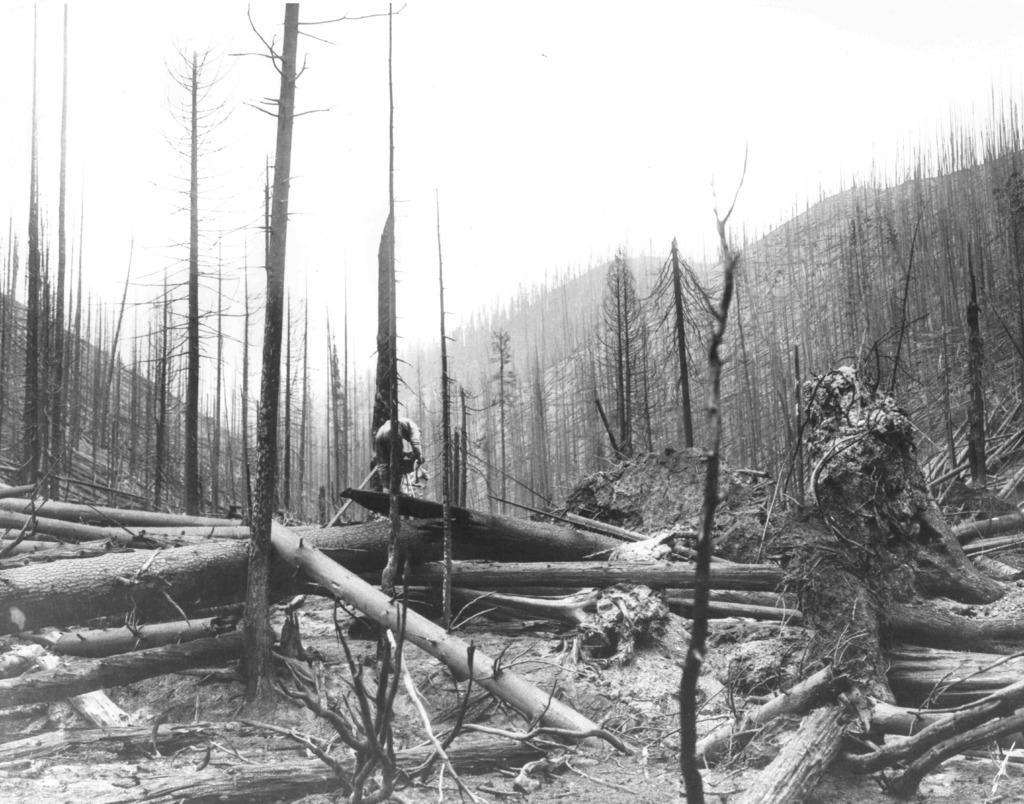Could you give a brief overview of what you see in this image? In this image I can see number of trees and I can also see number of tree trunks on the ground. I can also see this image is black and white in colour. 